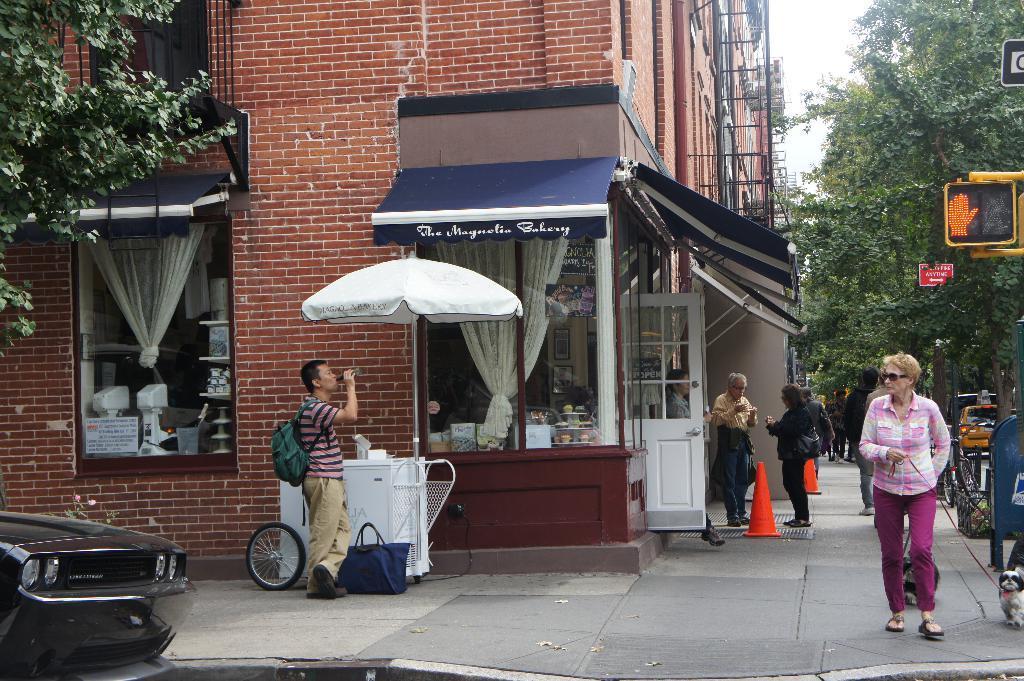Could you give a brief overview of what you see in this image? It is a street and there is a cafe below the building and many people are having food standing outside the cafe on the footpath and beside the footpath there are two vehicles and many trees and on the footpath a woman is is walking along with a dog,beside the dog there is a traffic signal pole it is showing orange signal and in the background there is a sky. 